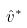Convert formula to latex. <formula><loc_0><loc_0><loc_500><loc_500>\hat { v } ^ { * }</formula> 